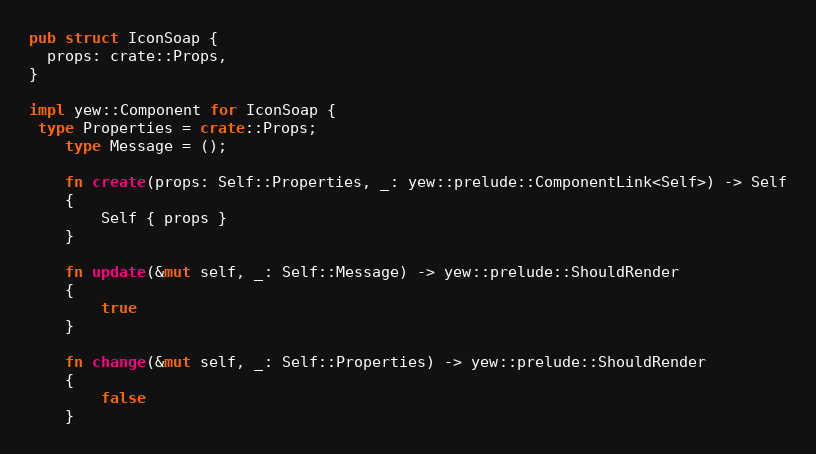Convert code to text. <code><loc_0><loc_0><loc_500><loc_500><_Rust_>
pub struct IconSoap {
  props: crate::Props,
}

impl yew::Component for IconSoap {
 type Properties = crate::Props;
    type Message = ();

    fn create(props: Self::Properties, _: yew::prelude::ComponentLink<Self>) -> Self
    {
        Self { props }
    }

    fn update(&mut self, _: Self::Message) -> yew::prelude::ShouldRender
    {
        true
    }

    fn change(&mut self, _: Self::Properties) -> yew::prelude::ShouldRender
    {
        false
    }
</code> 